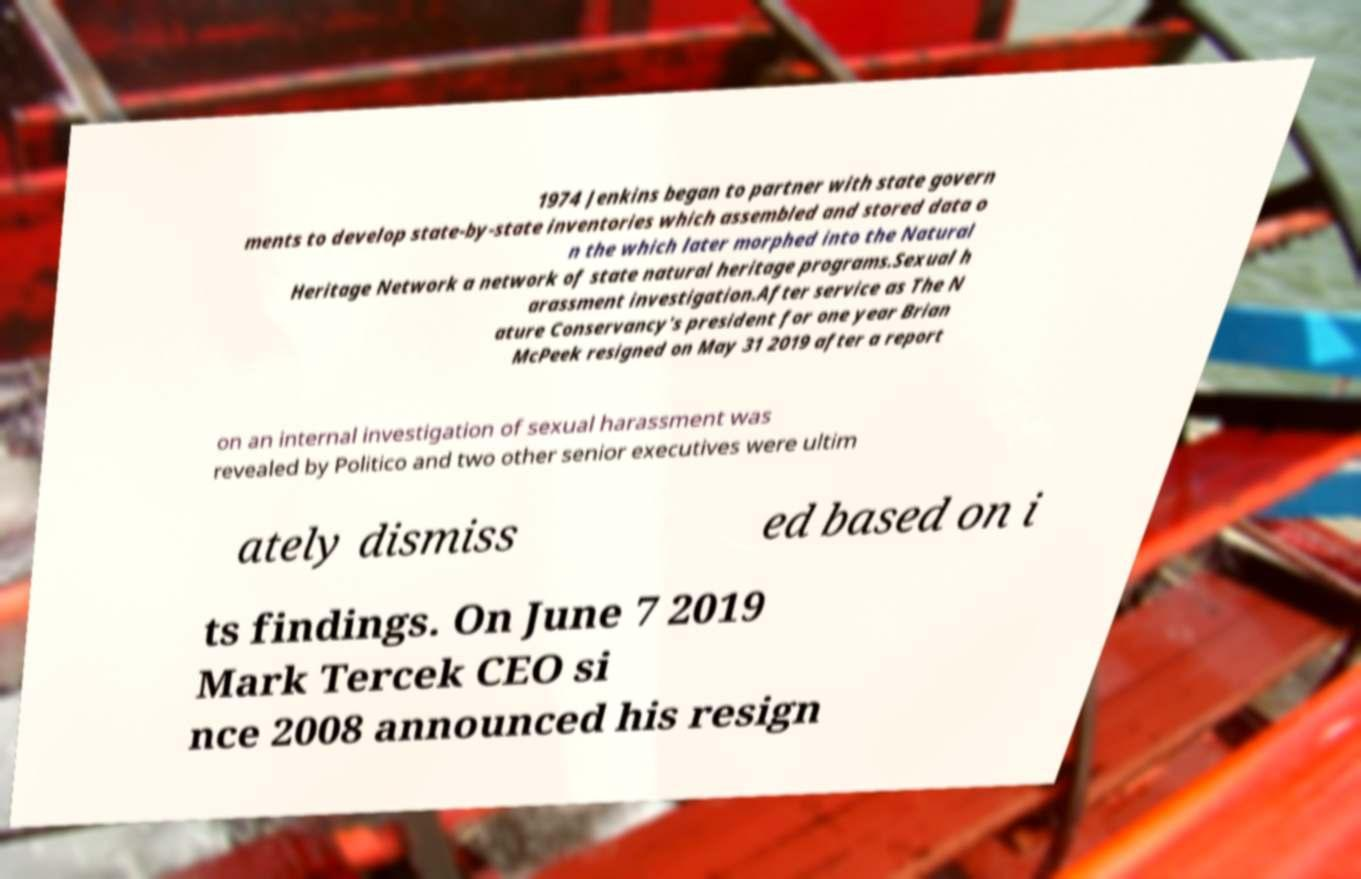What messages or text are displayed in this image? I need them in a readable, typed format. 1974 Jenkins began to partner with state govern ments to develop state-by-state inventories which assembled and stored data o n the which later morphed into the Natural Heritage Network a network of state natural heritage programs.Sexual h arassment investigation.After service as The N ature Conservancy's president for one year Brian McPeek resigned on May 31 2019 after a report on an internal investigation of sexual harassment was revealed by Politico and two other senior executives were ultim ately dismiss ed based on i ts findings. On June 7 2019 Mark Tercek CEO si nce 2008 announced his resign 